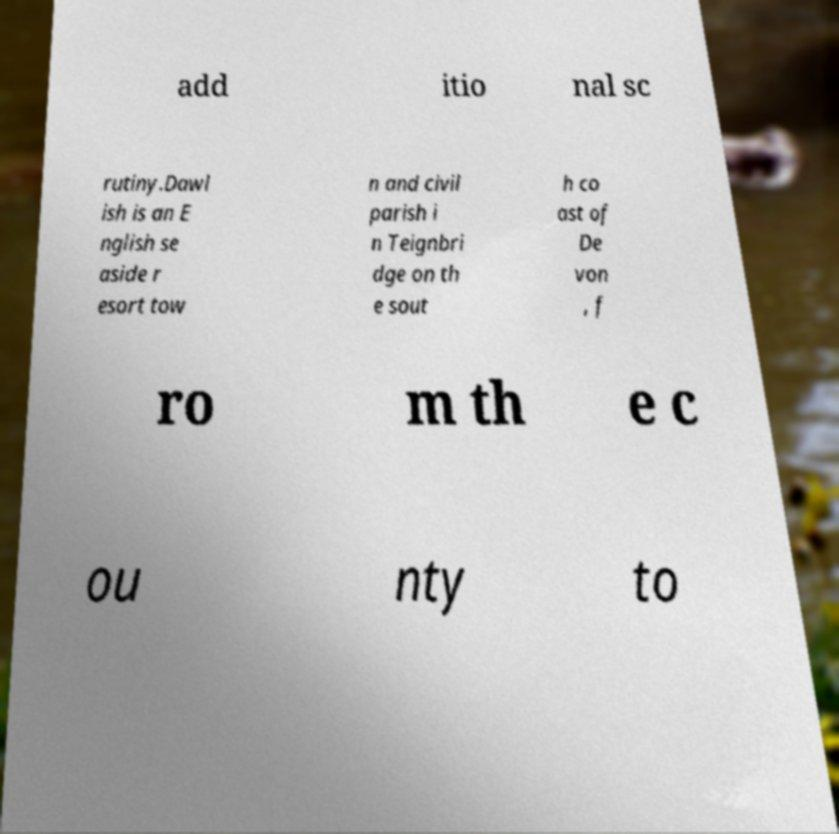Could you assist in decoding the text presented in this image and type it out clearly? add itio nal sc rutiny.Dawl ish is an E nglish se aside r esort tow n and civil parish i n Teignbri dge on th e sout h co ast of De von , f ro m th e c ou nty to 